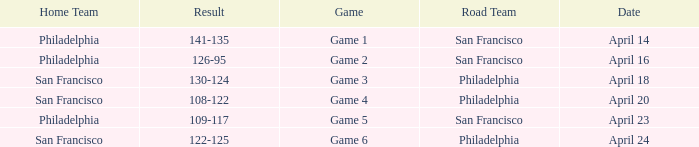On what date was game 2 played? April 16. 